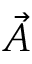Convert formula to latex. <formula><loc_0><loc_0><loc_500><loc_500>\ V e c { A }</formula> 